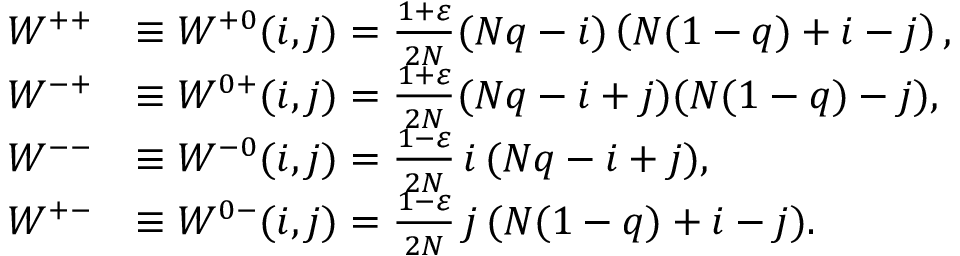<formula> <loc_0><loc_0><loc_500><loc_500>\begin{array} { r l } { W ^ { + + } } & { \equiv W ^ { + 0 } ( i , j ) = \frac { 1 + \varepsilon } { 2 N } ( N q - i ) \left ( N ( 1 - q ) + i - j \right ) , } \\ { W ^ { - + } } & { \equiv W ^ { 0 + } ( i , j ) = \frac { 1 + \varepsilon } { 2 N } ( N q - i + j ) ( N ( 1 - q ) - j ) , } \\ { W ^ { - - } } & { \equiv W ^ { - 0 } ( i , j ) = \frac { 1 - \varepsilon } { 2 N } i ( N q - i + j ) , } \\ { W ^ { + - } } & { \equiv W ^ { 0 - } ( i , j ) = \frac { 1 - \varepsilon } { 2 N } j ( N ( 1 - q ) + i - j ) . } \end{array}</formula> 